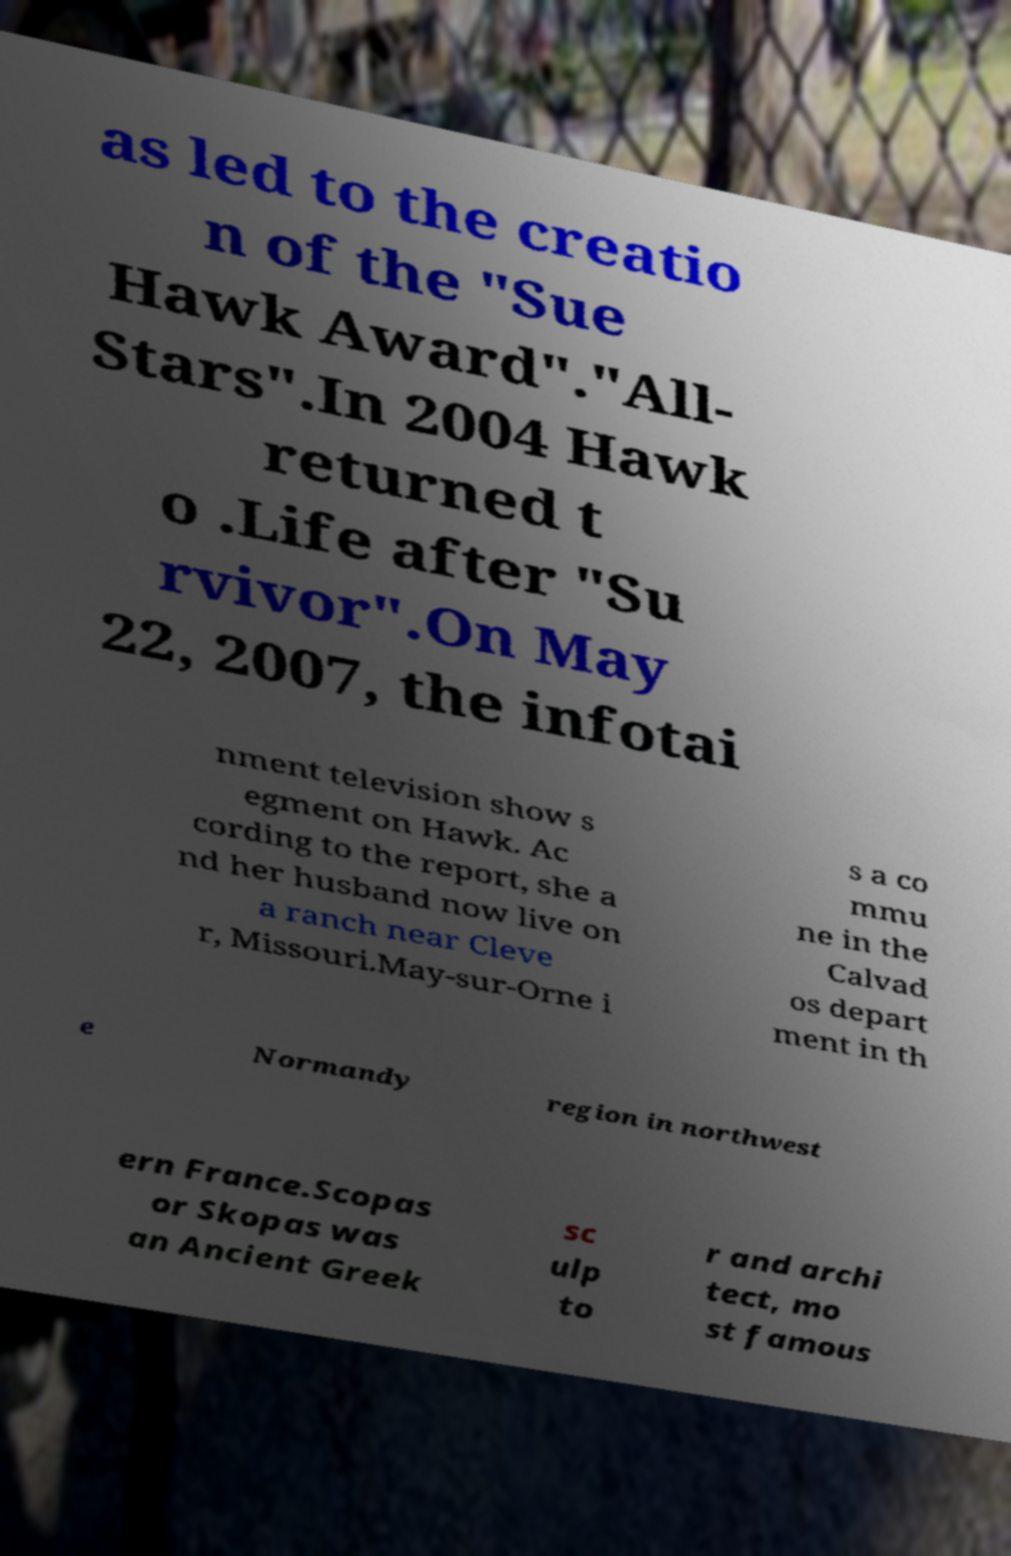Can you read and provide the text displayed in the image?This photo seems to have some interesting text. Can you extract and type it out for me? as led to the creatio n of the "Sue Hawk Award"."All- Stars".In 2004 Hawk returned t o .Life after "Su rvivor".On May 22, 2007, the infotai nment television show s egment on Hawk. Ac cording to the report, she a nd her husband now live on a ranch near Cleve r, Missouri.May-sur-Orne i s a co mmu ne in the Calvad os depart ment in th e Normandy region in northwest ern France.Scopas or Skopas was an Ancient Greek sc ulp to r and archi tect, mo st famous 